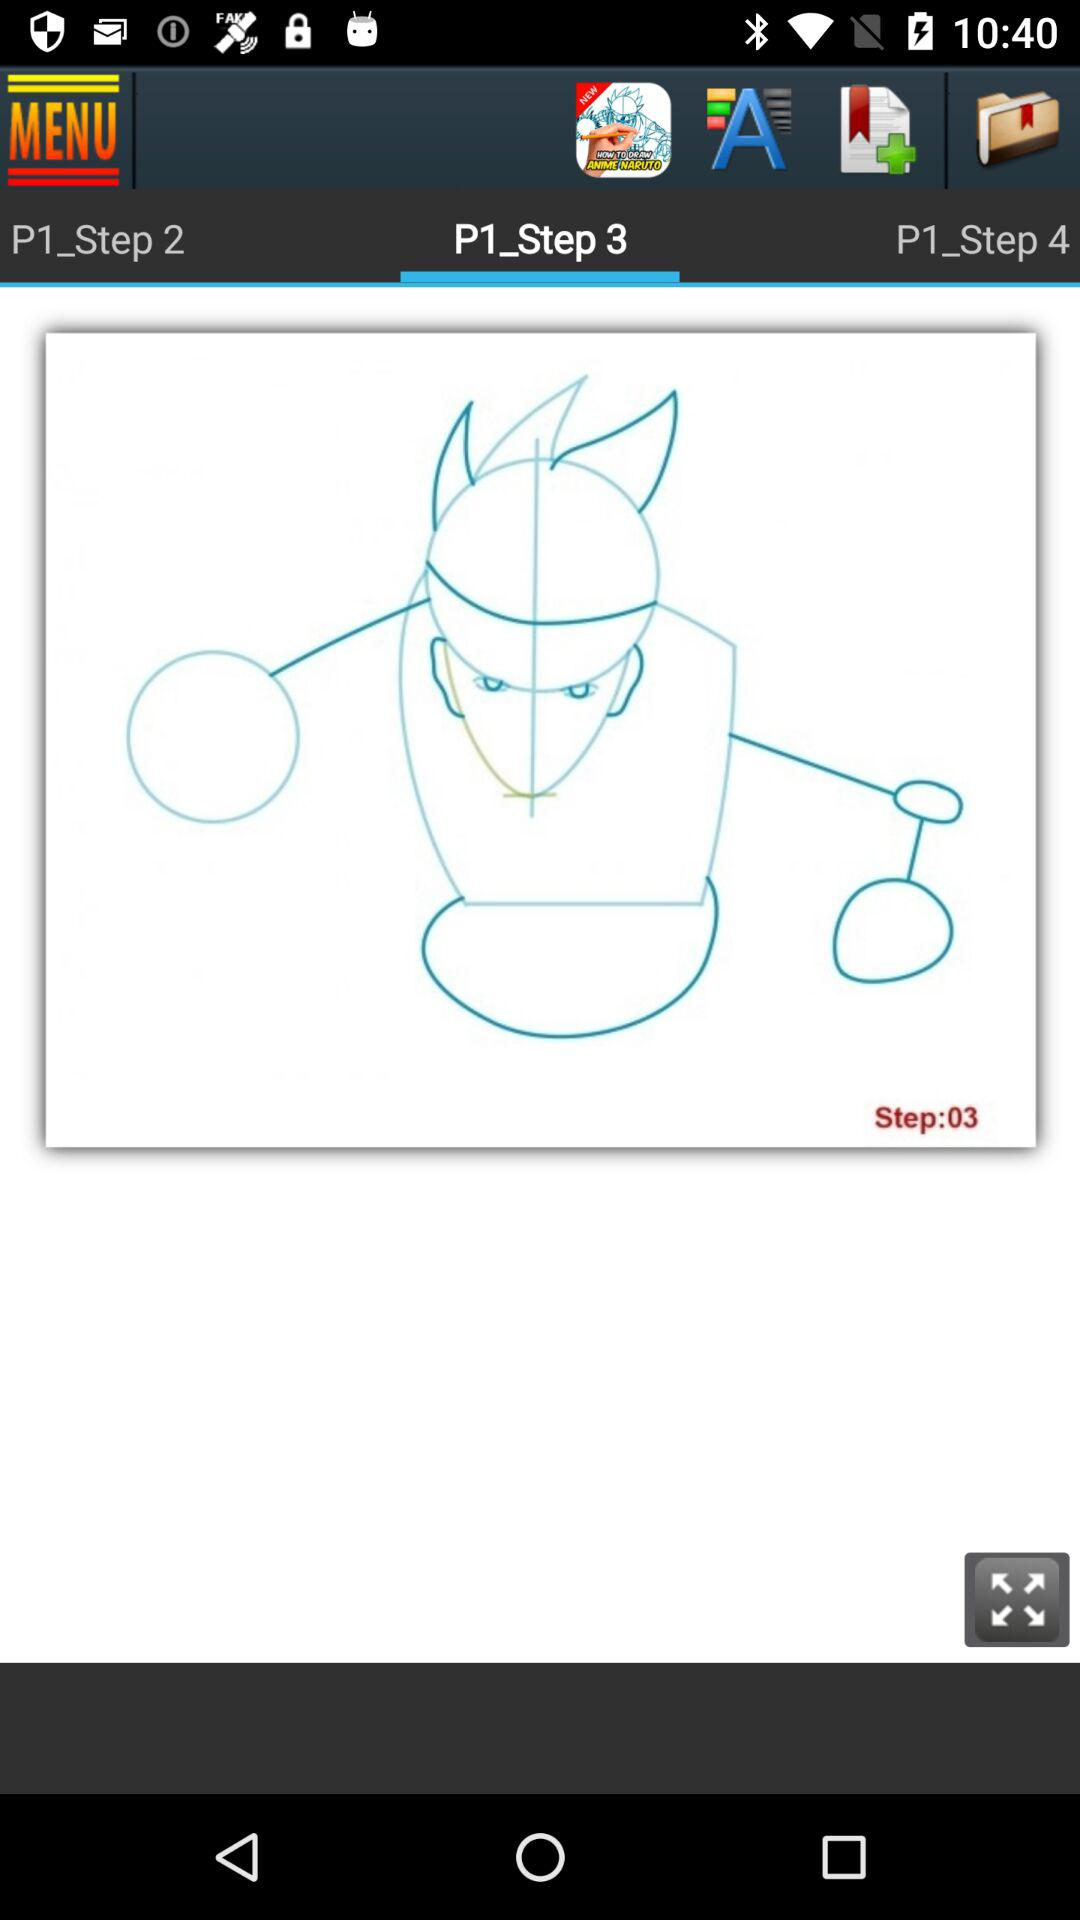How many more steps are there in this tutorial than there are bookmarks?
Answer the question using a single word or phrase. 1 